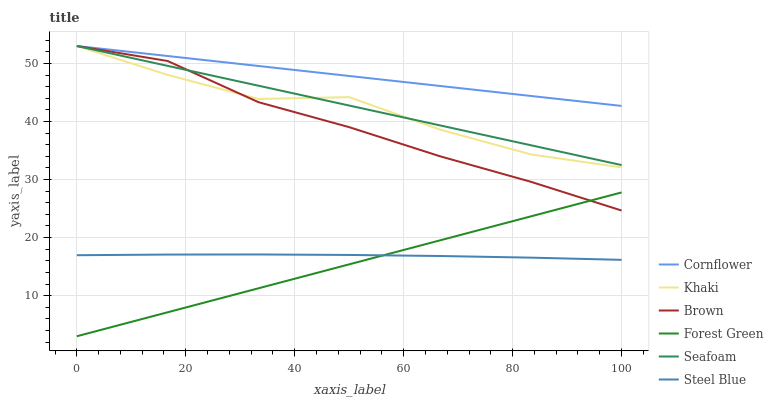Does Forest Green have the minimum area under the curve?
Answer yes or no. Yes. Does Cornflower have the maximum area under the curve?
Answer yes or no. Yes. Does Khaki have the minimum area under the curve?
Answer yes or no. No. Does Khaki have the maximum area under the curve?
Answer yes or no. No. Is Seafoam the smoothest?
Answer yes or no. Yes. Is Khaki the roughest?
Answer yes or no. Yes. Is Brown the smoothest?
Answer yes or no. No. Is Brown the roughest?
Answer yes or no. No. Does Forest Green have the lowest value?
Answer yes or no. Yes. Does Khaki have the lowest value?
Answer yes or no. No. Does Seafoam have the highest value?
Answer yes or no. Yes. Does Steel Blue have the highest value?
Answer yes or no. No. Is Steel Blue less than Brown?
Answer yes or no. Yes. Is Cornflower greater than Forest Green?
Answer yes or no. Yes. Does Khaki intersect Cornflower?
Answer yes or no. Yes. Is Khaki less than Cornflower?
Answer yes or no. No. Is Khaki greater than Cornflower?
Answer yes or no. No. Does Steel Blue intersect Brown?
Answer yes or no. No. 